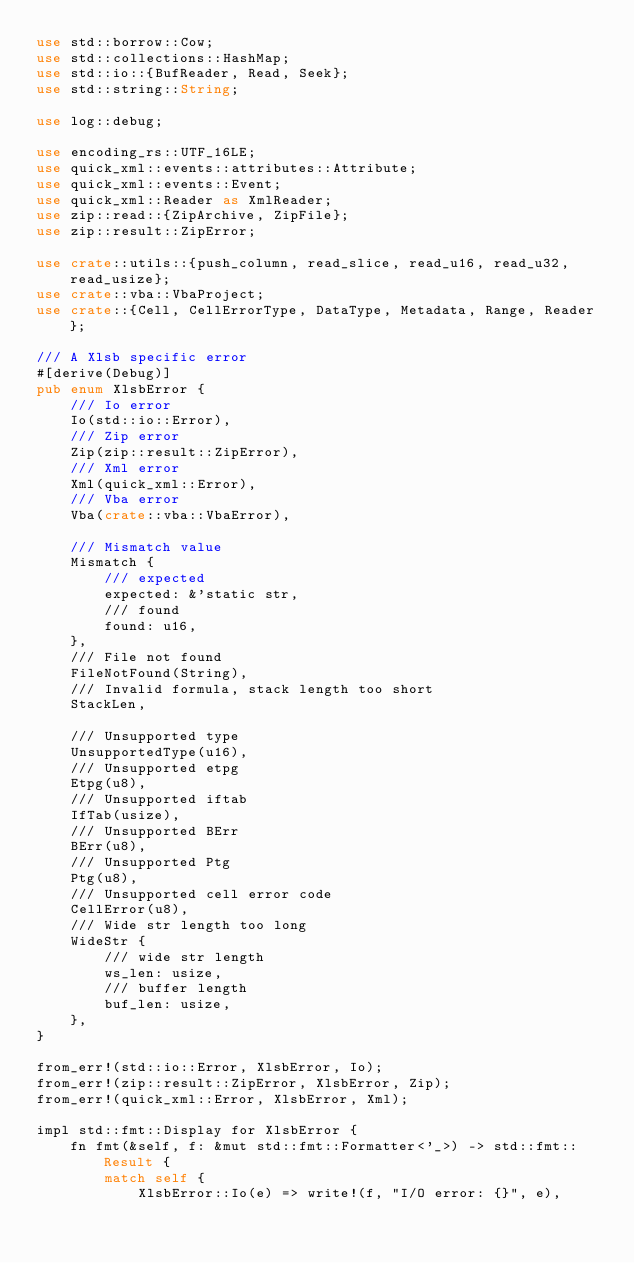Convert code to text. <code><loc_0><loc_0><loc_500><loc_500><_Rust_>use std::borrow::Cow;
use std::collections::HashMap;
use std::io::{BufReader, Read, Seek};
use std::string::String;

use log::debug;

use encoding_rs::UTF_16LE;
use quick_xml::events::attributes::Attribute;
use quick_xml::events::Event;
use quick_xml::Reader as XmlReader;
use zip::read::{ZipArchive, ZipFile};
use zip::result::ZipError;

use crate::utils::{push_column, read_slice, read_u16, read_u32, read_usize};
use crate::vba::VbaProject;
use crate::{Cell, CellErrorType, DataType, Metadata, Range, Reader};

/// A Xlsb specific error
#[derive(Debug)]
pub enum XlsbError {
    /// Io error
    Io(std::io::Error),
    /// Zip error
    Zip(zip::result::ZipError),
    /// Xml error
    Xml(quick_xml::Error),
    /// Vba error
    Vba(crate::vba::VbaError),

    /// Mismatch value
    Mismatch {
        /// expected
        expected: &'static str,
        /// found
        found: u16,
    },
    /// File not found
    FileNotFound(String),
    /// Invalid formula, stack length too short
    StackLen,

    /// Unsupported type
    UnsupportedType(u16),
    /// Unsupported etpg
    Etpg(u8),
    /// Unsupported iftab
    IfTab(usize),
    /// Unsupported BErr
    BErr(u8),
    /// Unsupported Ptg
    Ptg(u8),
    /// Unsupported cell error code
    CellError(u8),
    /// Wide str length too long
    WideStr {
        /// wide str length
        ws_len: usize,
        /// buffer length
        buf_len: usize,
    },
}

from_err!(std::io::Error, XlsbError, Io);
from_err!(zip::result::ZipError, XlsbError, Zip);
from_err!(quick_xml::Error, XlsbError, Xml);

impl std::fmt::Display for XlsbError {
    fn fmt(&self, f: &mut std::fmt::Formatter<'_>) -> std::fmt::Result {
        match self {
            XlsbError::Io(e) => write!(f, "I/O error: {}", e),</code> 